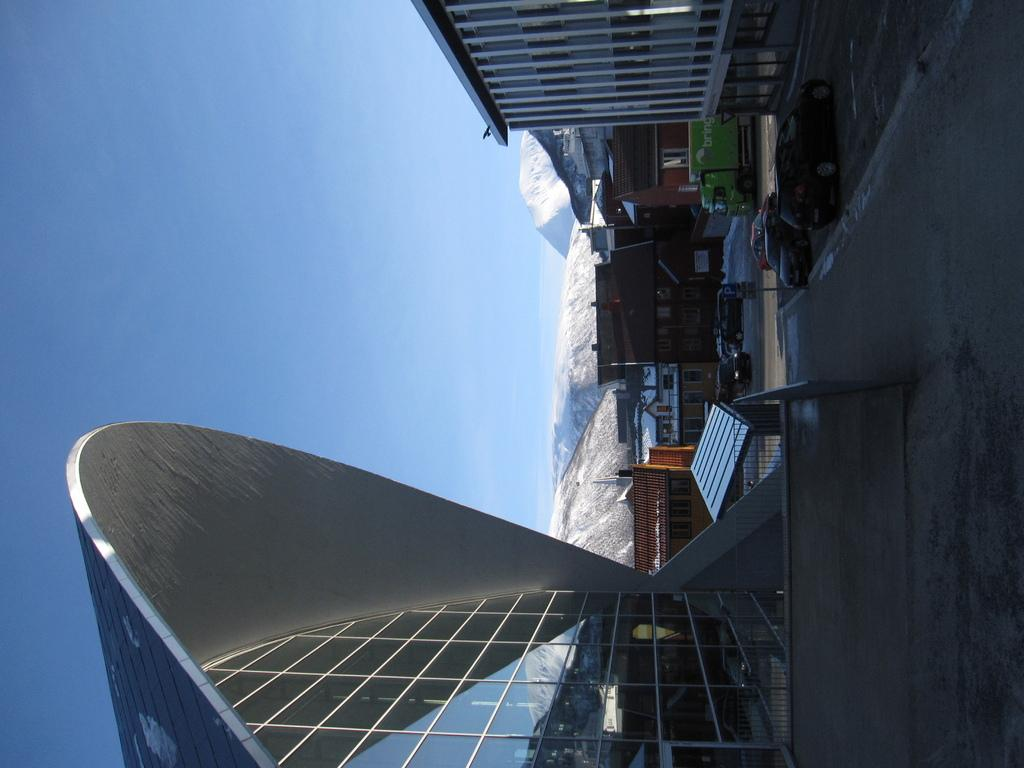What type of structures can be seen in the image? There are buildings in the image. What can be found on the right side of the image? Cars are parked on the road on the right side of the image. What is visible in the background of the image? There are mountains in the background of the image. What is the condition of the mountains? The mountains are covered with snow. What is visible at the top of the image? The sky is visible at the top of the image. What type of brush is used to paint the patch on the car in the image? There is no brush or patch present on the cars in the image; they are parked with no visible modifications. 